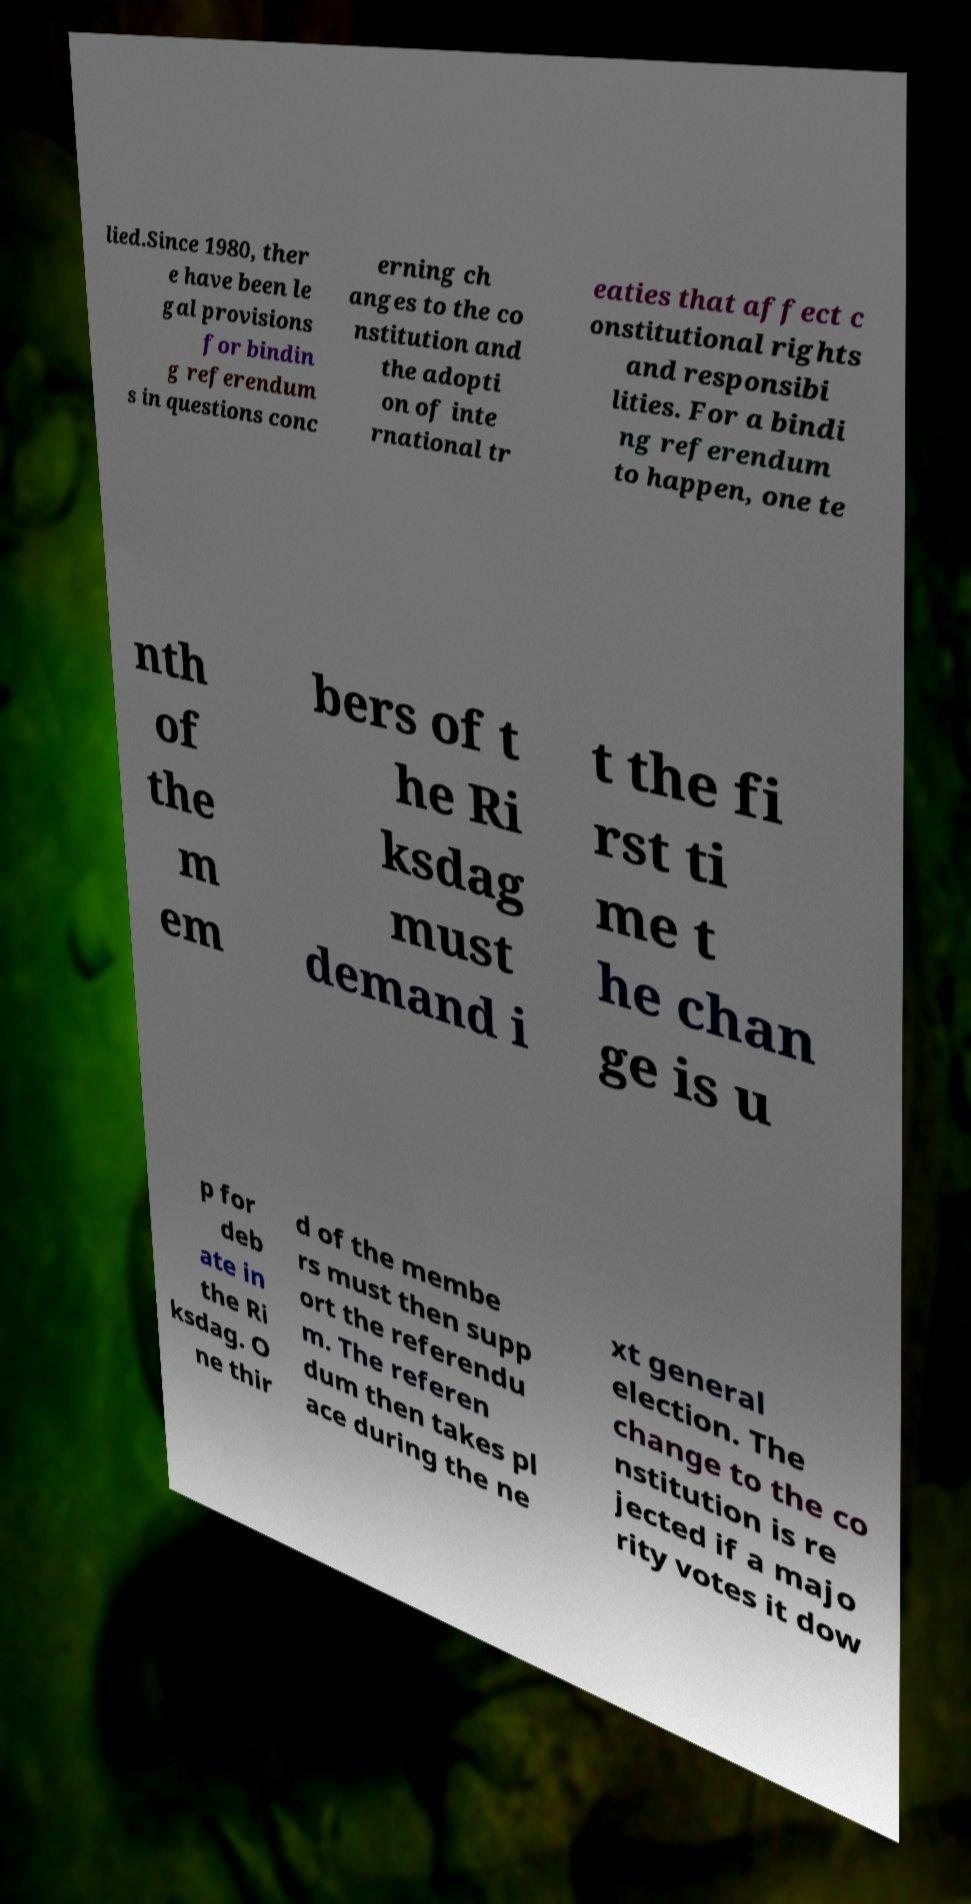For documentation purposes, I need the text within this image transcribed. Could you provide that? lied.Since 1980, ther e have been le gal provisions for bindin g referendum s in questions conc erning ch anges to the co nstitution and the adopti on of inte rnational tr eaties that affect c onstitutional rights and responsibi lities. For a bindi ng referendum to happen, one te nth of the m em bers of t he Ri ksdag must demand i t the fi rst ti me t he chan ge is u p for deb ate in the Ri ksdag. O ne thir d of the membe rs must then supp ort the referendu m. The referen dum then takes pl ace during the ne xt general election. The change to the co nstitution is re jected if a majo rity votes it dow 